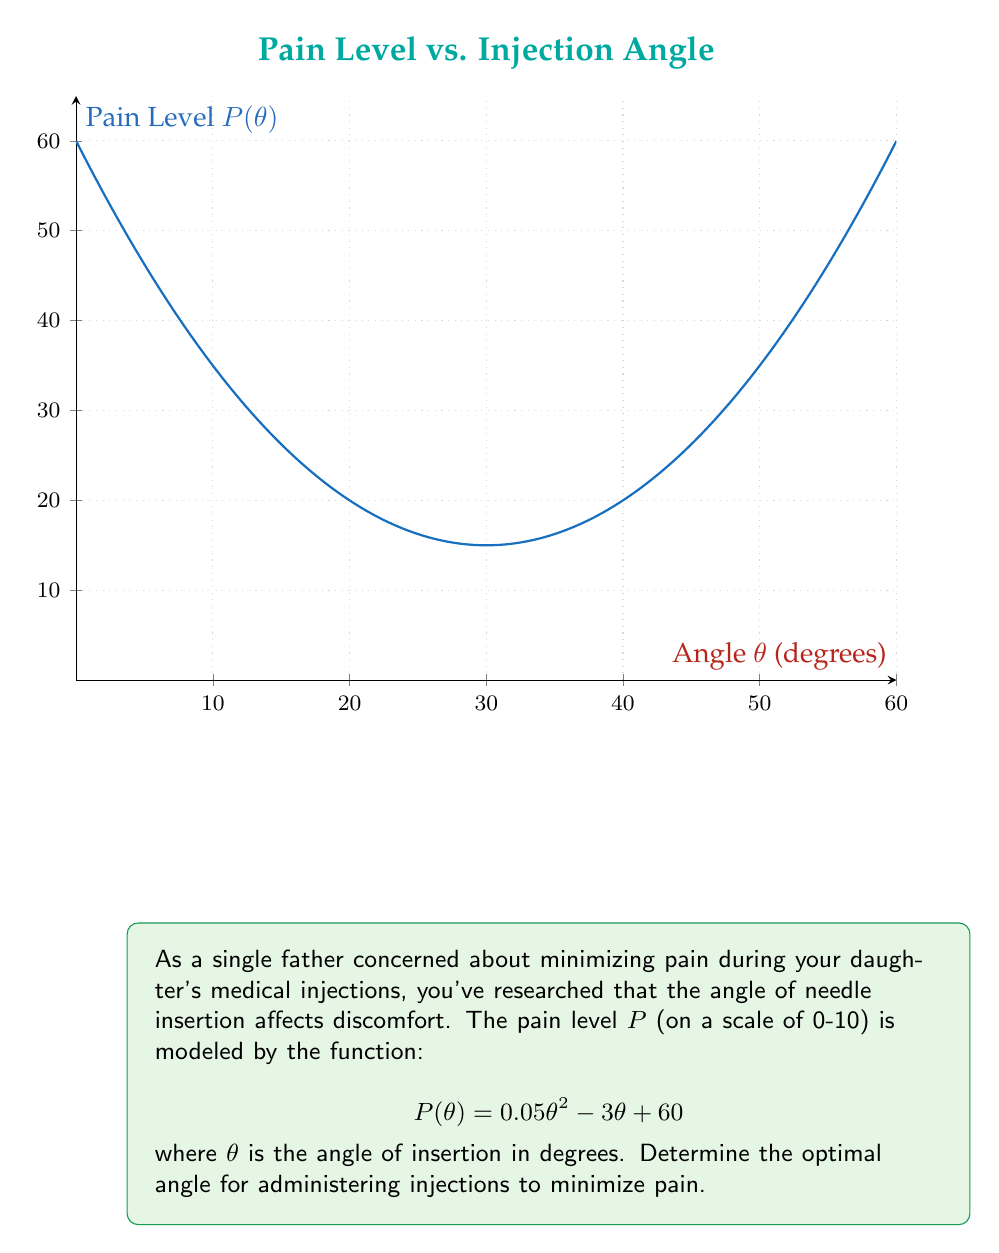Teach me how to tackle this problem. To find the optimal angle that minimizes pain, we need to find the minimum point of the function $P(\theta)$. This can be done by following these steps:

1) Find the derivative of $P(\theta)$:
   $$P'(\theta) = 0.1\theta - 3$$

2) Set the derivative equal to zero and solve for $\theta$:
   $$0.1\theta - 3 = 0$$
   $$0.1\theta = 3$$
   $$\theta = 30$$

3) To confirm this is a minimum (not a maximum), check the second derivative:
   $$P''(\theta) = 0.1$$
   Since $P''(\theta) > 0$, the critical point is indeed a minimum.

4) Therefore, the pain is minimized when $\theta = 30$ degrees.

5) To find the minimum pain level, substitute $\theta = 30$ into the original function:
   $$P(30) = 0.05(30)^2 - 3(30) + 60$$
   $$= 0.05(900) - 90 + 60$$
   $$= 45 - 90 + 60$$
   $$= 15$$

Thus, the optimal angle for administering injections is 30 degrees, resulting in a minimum pain level of 15 on the given scale.
Answer: 30 degrees 